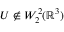<formula> <loc_0><loc_0><loc_500><loc_500>U \not \in W _ { 2 } ^ { 2 } ( { \mathbb { R } } ^ { 3 } )</formula> 